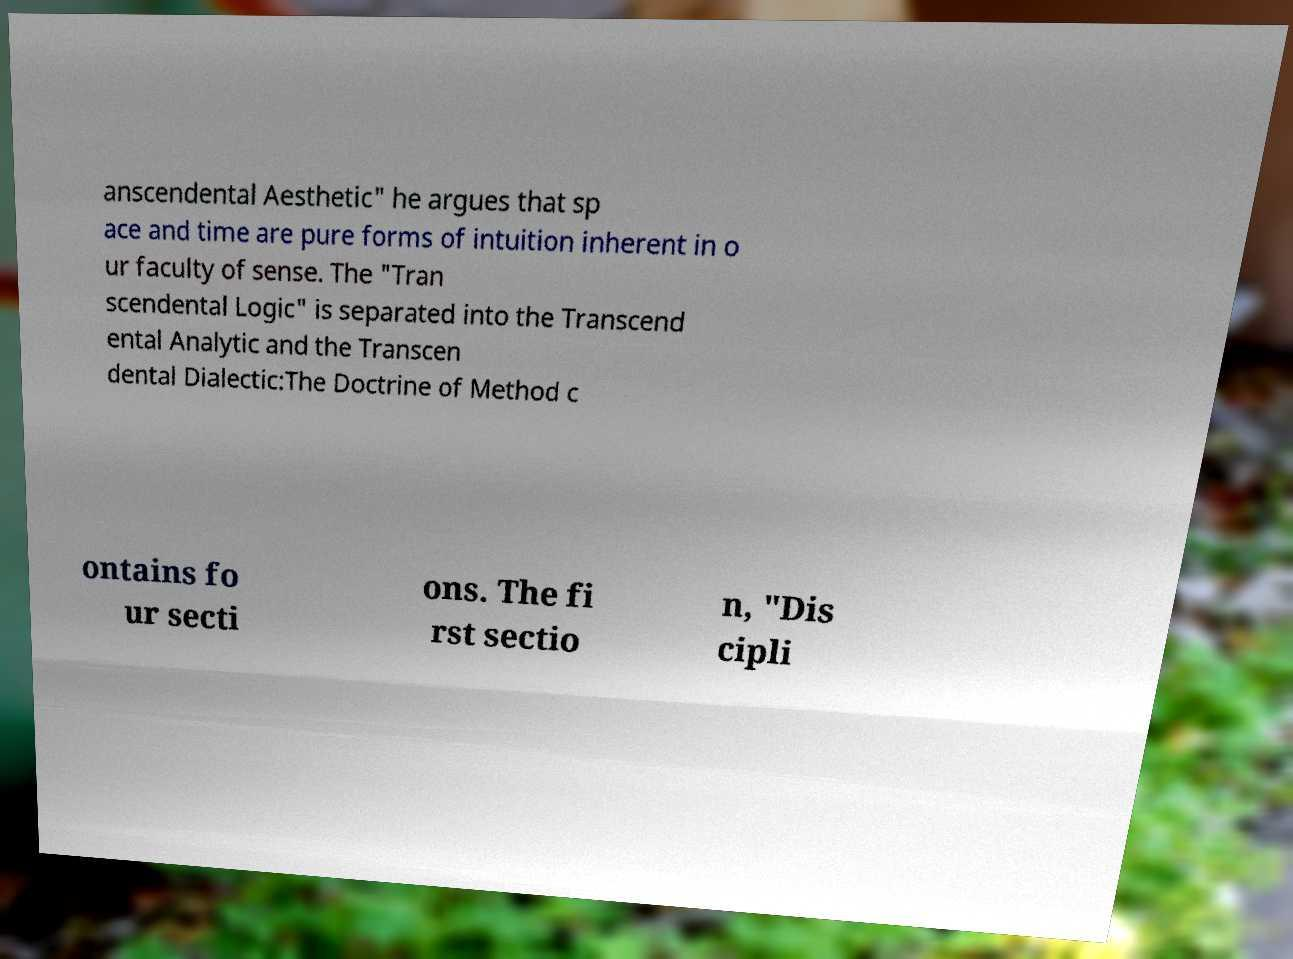There's text embedded in this image that I need extracted. Can you transcribe it verbatim? anscendental Aesthetic" he argues that sp ace and time are pure forms of intuition inherent in o ur faculty of sense. The "Tran scendental Logic" is separated into the Transcend ental Analytic and the Transcen dental Dialectic:The Doctrine of Method c ontains fo ur secti ons. The fi rst sectio n, "Dis cipli 